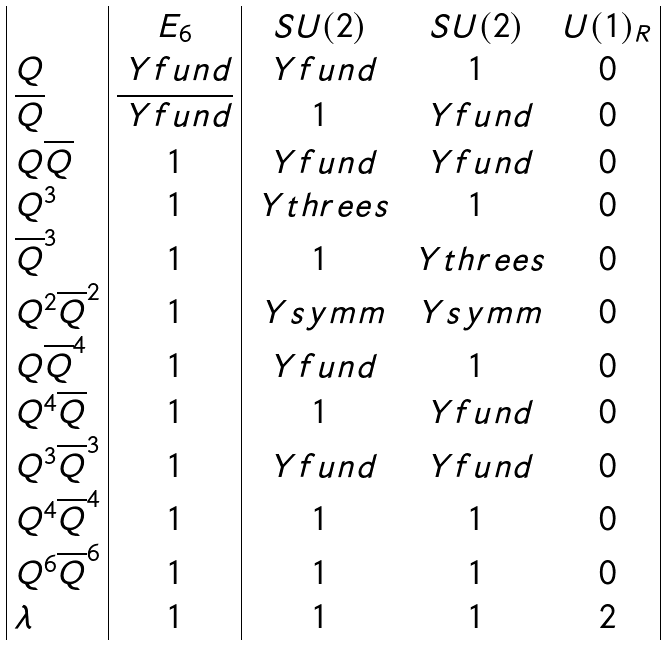Convert formula to latex. <formula><loc_0><loc_0><loc_500><loc_500>\begin{array} { | l | c | c c c | } & E _ { 6 } & S U ( 2 ) & S U ( 2 ) & U ( 1 ) _ { R } \\ Q & \ Y f u n d & \ Y f u n d & 1 & 0 \\ \overline { Q } & \overline { \ Y f u n d } & 1 & \ Y f u n d & 0 \\ Q \overline { Q } & 1 & \ Y f u n d & \ Y f u n d & 0 \\ Q ^ { 3 } & 1 & \ Y t h r e e s & 1 & 0 \\ \overline { Q } ^ { 3 } & 1 & 1 & \ Y t h r e e s & 0 \\ Q ^ { 2 } \overline { Q } ^ { 2 } & 1 & \ Y s y m m & \ Y s y m m & 0 \\ Q \overline { Q } ^ { 4 } & 1 & \ Y f u n d & 1 & 0 \\ Q ^ { 4 } \overline { Q } & 1 & 1 & \ Y f u n d & 0 \\ Q ^ { 3 } \overline { Q } ^ { 3 } & 1 & \ Y f u n d & \ Y f u n d & 0 \\ Q ^ { 4 } \overline { Q } ^ { 4 } & 1 & 1 & 1 & 0 \\ Q ^ { 6 } \overline { Q } ^ { 6 } & 1 & 1 & 1 & 0 \\ \lambda & 1 & 1 & 1 & 2 \\ \end{array}</formula> 